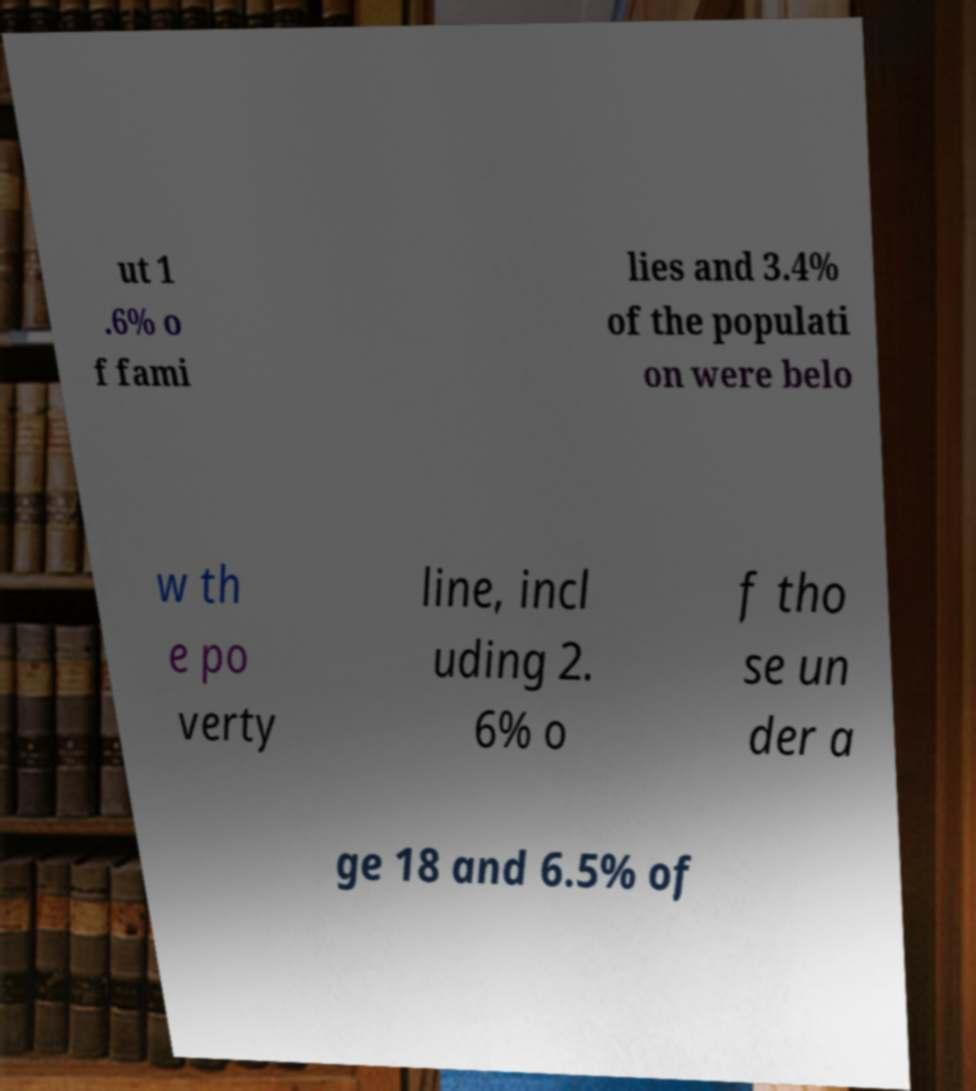Can you read and provide the text displayed in the image?This photo seems to have some interesting text. Can you extract and type it out for me? ut 1 .6% o f fami lies and 3.4% of the populati on were belo w th e po verty line, incl uding 2. 6% o f tho se un der a ge 18 and 6.5% of 